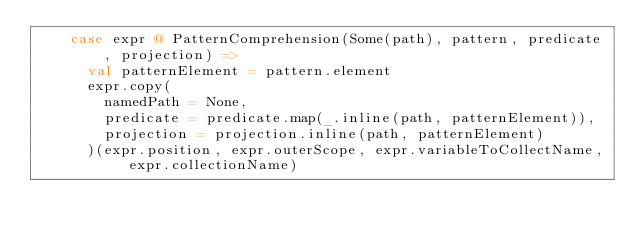<code> <loc_0><loc_0><loc_500><loc_500><_Scala_>    case expr @ PatternComprehension(Some(path), pattern, predicate, projection) =>
      val patternElement = pattern.element
      expr.copy(
        namedPath = None,
        predicate = predicate.map(_.inline(path, patternElement)),
        projection = projection.inline(path, patternElement)
      )(expr.position, expr.outerScope, expr.variableToCollectName, expr.collectionName)</code> 